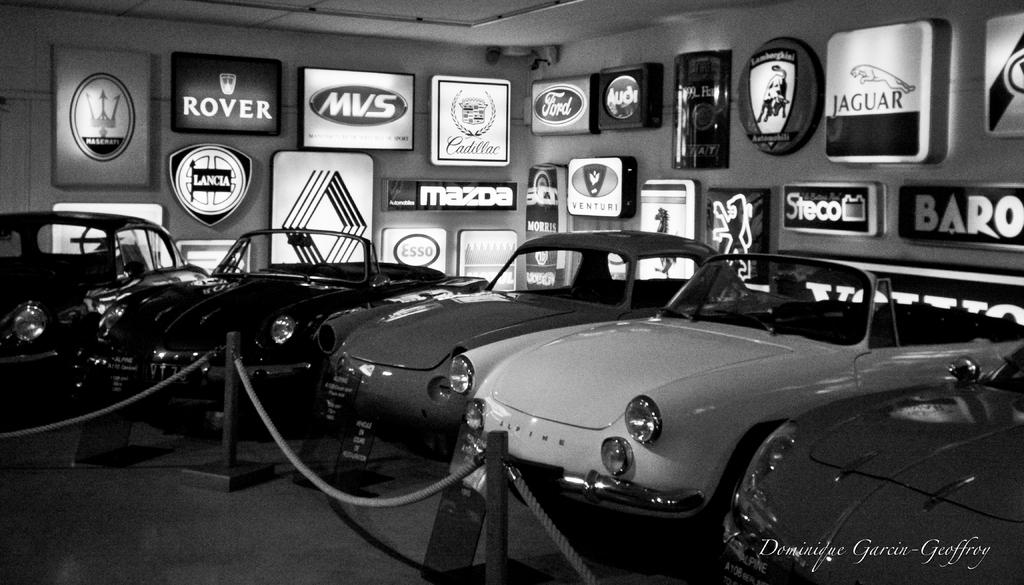What is the color scheme of the image? The image is black and white. What objects can be seen on the floor in the image? There are vehicles on the floor. What is the rope used for in the image? The purpose of the rope is not clear from the image, but it is present. What type of barrier is visible in the image? There is a pole barrier in the image. What type of lighting is present in the image? There are light boards on the wall and ceiling. What type of table is being used as a representative in the image? There is no table present in the image, and no representative is mentioned or depicted. 